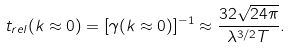<formula> <loc_0><loc_0><loc_500><loc_500>t _ { r e l } ( k \approx 0 ) = [ \gamma ( { k \approx 0 } ) ] ^ { - 1 } \approx \frac { 3 2 \sqrt { 2 4 \pi } } { \lambda ^ { 3 / 2 } T } .</formula> 